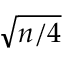Convert formula to latex. <formula><loc_0><loc_0><loc_500><loc_500>\sqrt { n / 4 }</formula> 